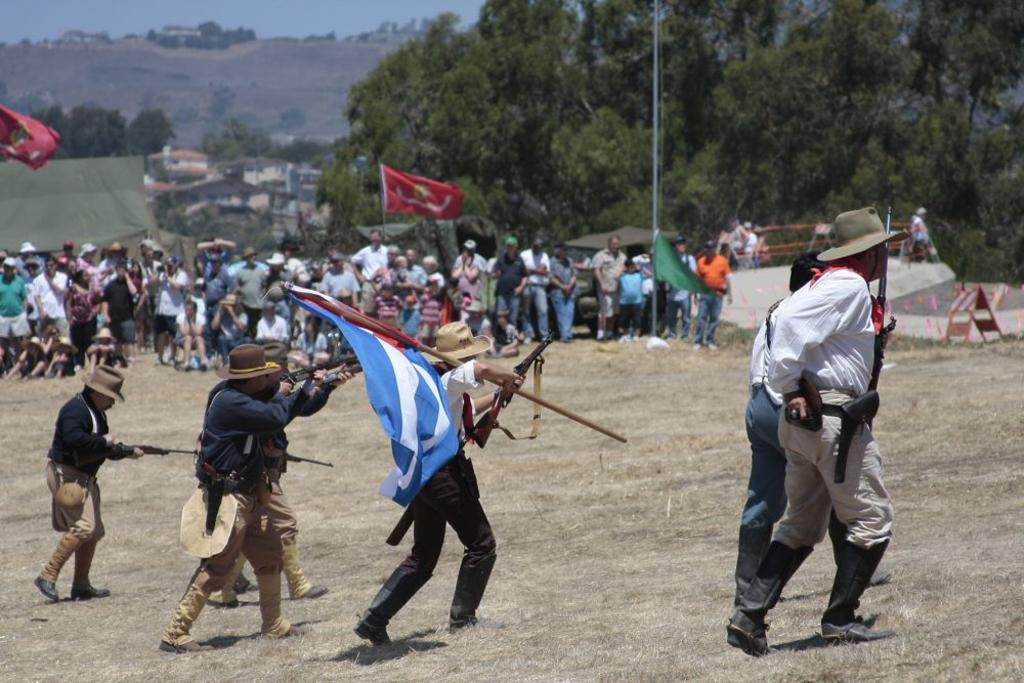What are the persons in the image holding? The persons in the image are holding weapons. Can you describe the people in the background of the image? There are people in the background of the image, but their specific actions or characteristics are not mentioned in the facts. What type of natural environment can be seen in the image? Trees are visible in the image, indicating a natural environment. What type of shop can be seen in the image? There is no shop present in the image. What religious symbols can be seen in the image? The facts provided do not mention any religious symbols in the image. 